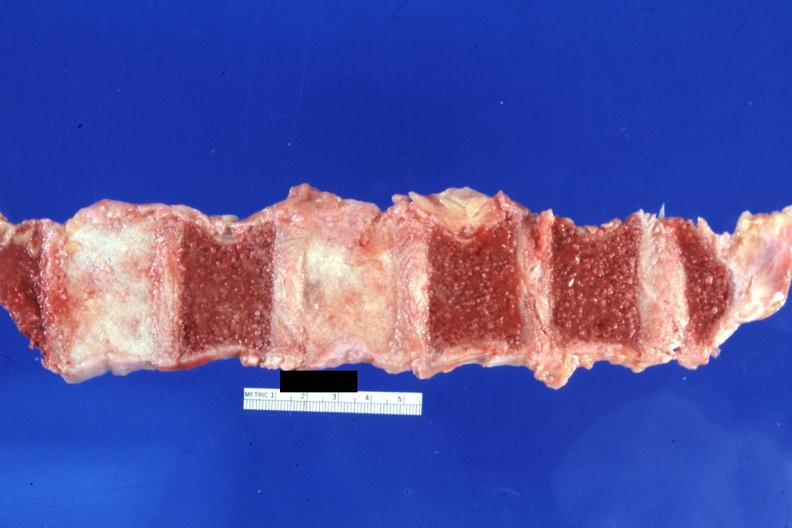what do typical ivory vertebra at this time diagnosis?
Answer the question using a single word or phrase. Not have history 